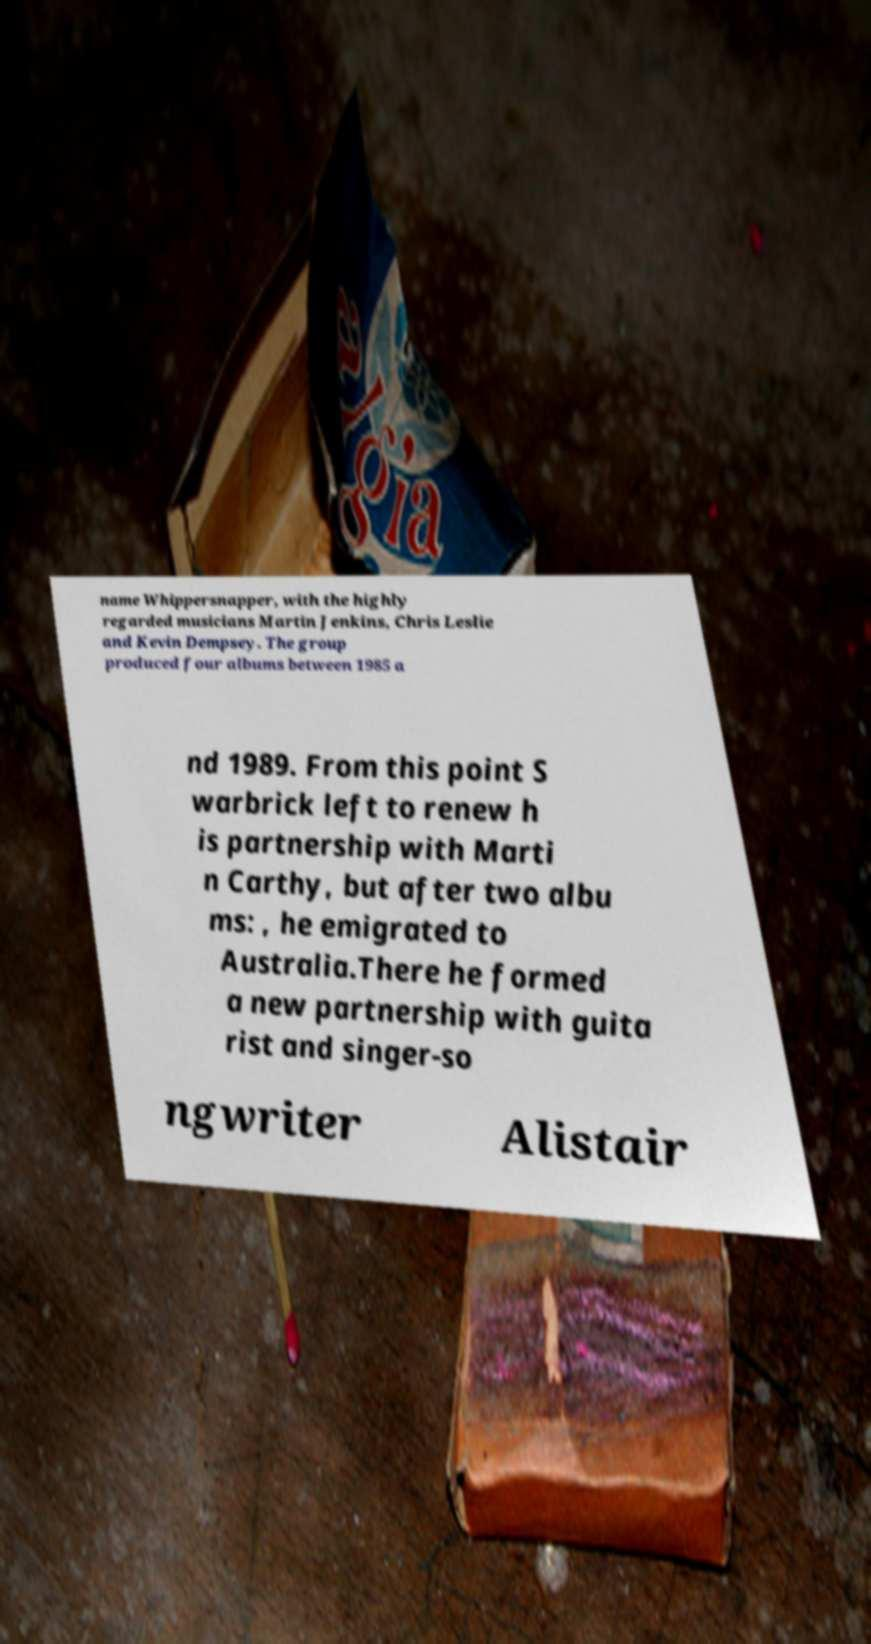Can you read and provide the text displayed in the image?This photo seems to have some interesting text. Can you extract and type it out for me? name Whippersnapper, with the highly regarded musicians Martin Jenkins, Chris Leslie and Kevin Dempsey. The group produced four albums between 1985 a nd 1989. From this point S warbrick left to renew h is partnership with Marti n Carthy, but after two albu ms: , he emigrated to Australia.There he formed a new partnership with guita rist and singer-so ngwriter Alistair 